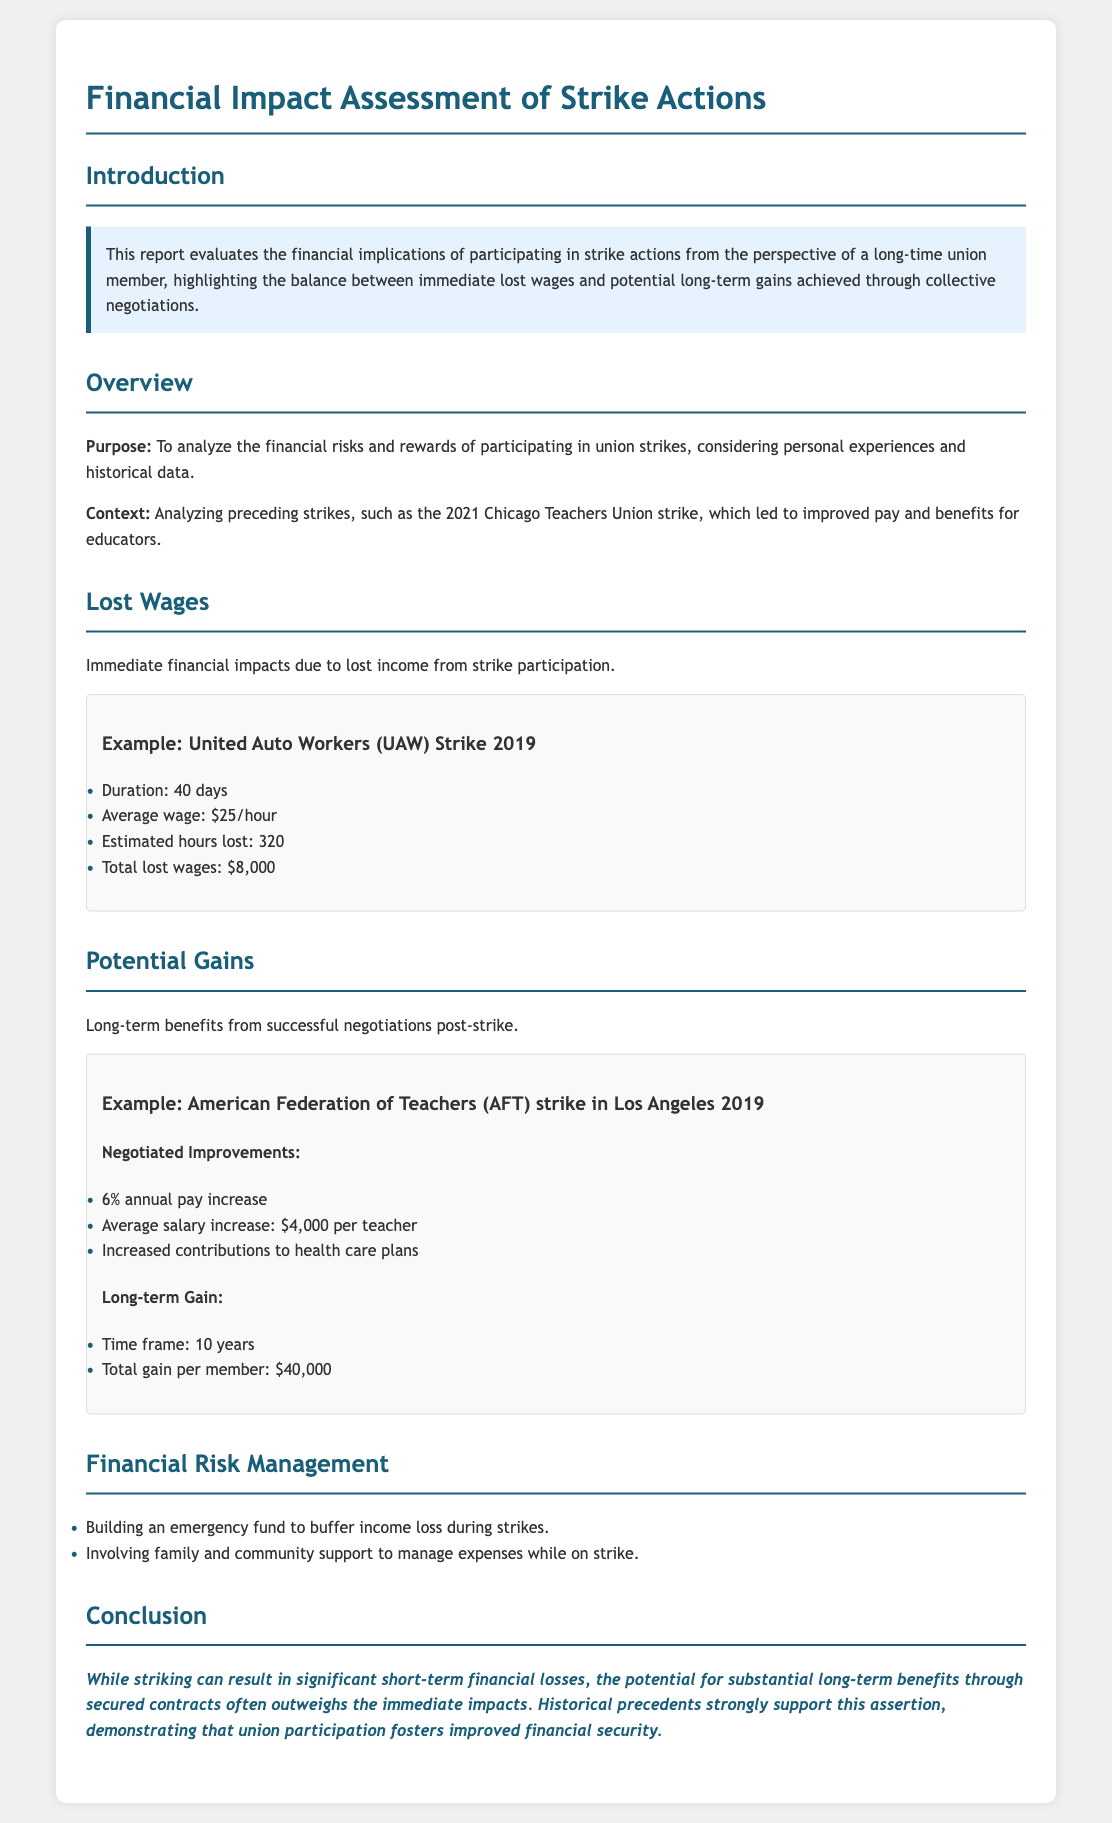what is the average wage during the UAW strike in 2019? The average wage during the UAW strike was mentioned as $25/hour.
Answer: $25/hour how many days did the UAW strike last? The UAW strike lasted for a duration of 40 days.
Answer: 40 days what was the total lost wages for the UAW strike? The total lost wages were calculated as $8,000 for the UAW strike.
Answer: $8,000 what percentage increase was negotiated in the AFT strike in Los Angeles? The negotiated improvement included a 6% annual pay increase.
Answer: 6% how much total gain was projected per member after the AFT strike? The total gain projected per member was stated as $40,000 over a 10-year period.
Answer: $40,000 what is a recommended method for financial risk management during strikes? The document suggests building an emergency fund to buffer income loss during strikes.
Answer: Building an emergency fund why might striking lead to improved financial security over time? Striking often results in substantial long-term benefits that outweigh immediate losses, backed by historical precedents.
Answer: Substantial long-term benefits what are two forms of support recommended for managing expenses during a strike? The report mentions involving family and community support to manage expenses while on strike.
Answer: Family and community support 